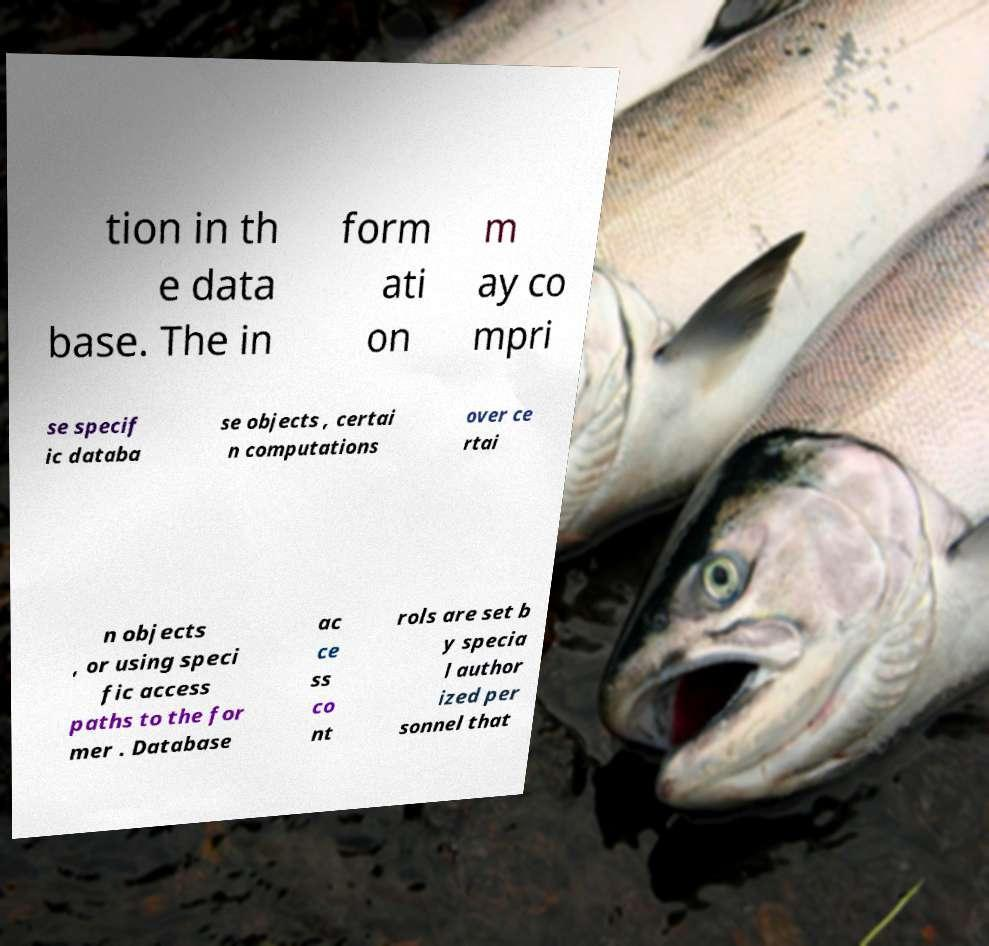What messages or text are displayed in this image? I need them in a readable, typed format. tion in th e data base. The in form ati on m ay co mpri se specif ic databa se objects , certai n computations over ce rtai n objects , or using speci fic access paths to the for mer . Database ac ce ss co nt rols are set b y specia l author ized per sonnel that 